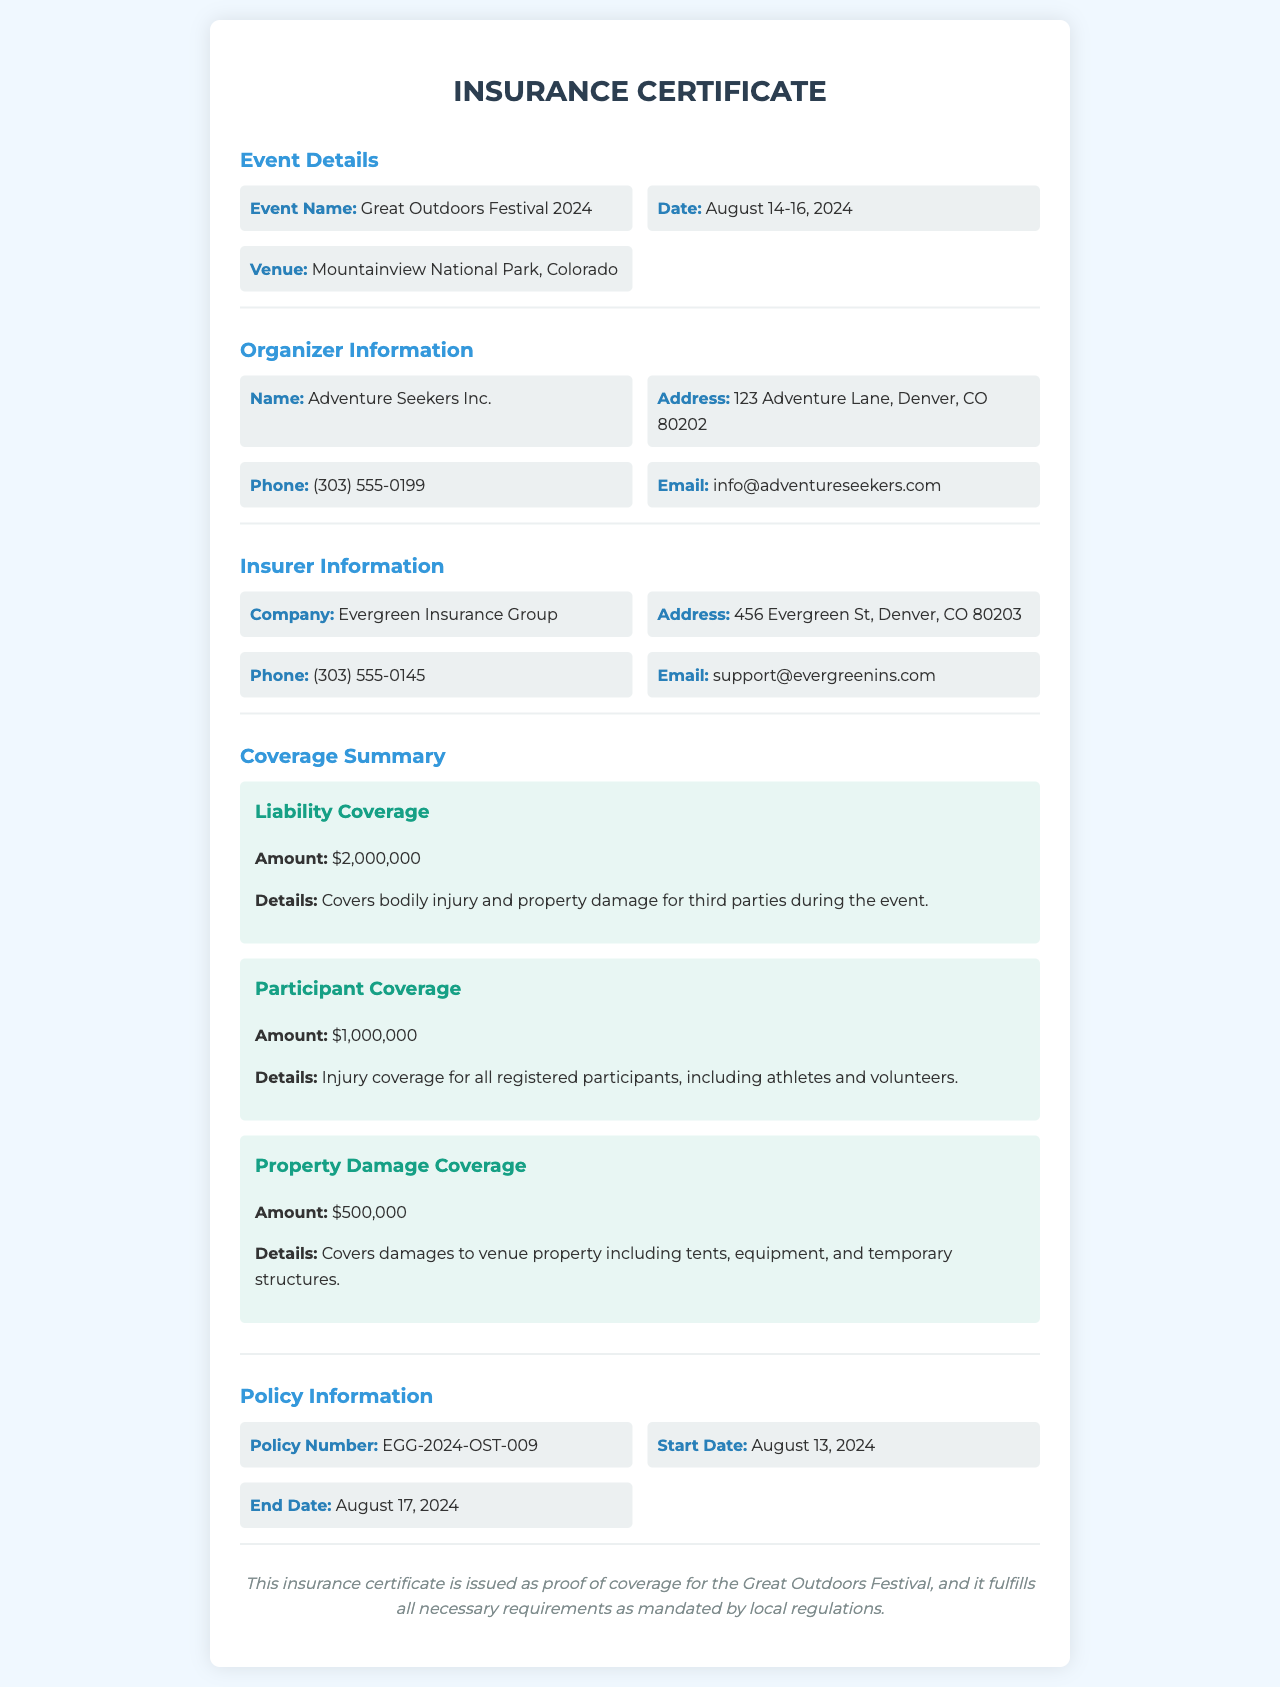What is the event name? The event name is listed under Event Details in the document.
Answer: Great Outdoors Festival 2024 What are the coverage amounts for liability? The document specifies the amount of liability coverage.
Answer: $2,000,000 What is the duration of the event? The duration of the event is indicated by the start and end dates listed in the document.
Answer: August 14-16, 2024 Who is the insurer? The insurer's information is detailed in the Insurer Information section.
Answer: Evergreen Insurance Group What is the policy number? The policy number can be found in the Policy Information section of the document.
Answer: EGG-2024-OST-009 What type of event is this insurance certificate for? The document specifies the type of event related to the insurance certificate.
Answer: Outdoor sports festival What is the start date of the insurance coverage? The start date is mentioned under Policy Information in the document.
Answer: August 13, 2024 What is covered under property damage coverage? The coverage details for property damage are outlined in the Coverage Summary section.
Answer: Damages to venue property How many days does the insurance cover the event? The coverage duration can be calculated based on the start and end date of the policy.
Answer: 5 days How can participants contact the organizer? The contact information for the organizer is provided under Organizer Information.
Answer: (303) 555-0199 